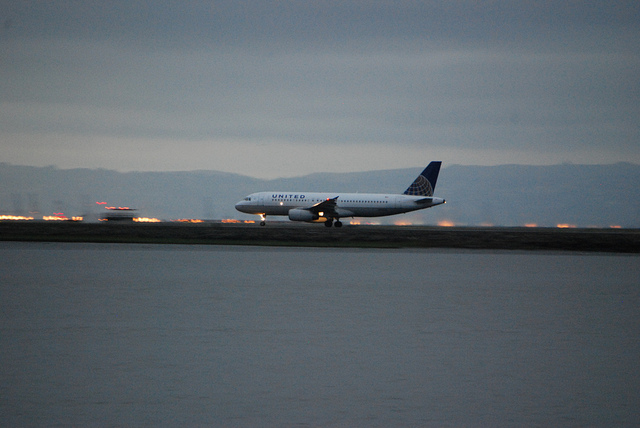Identify the text displayed in this image. UNITED 